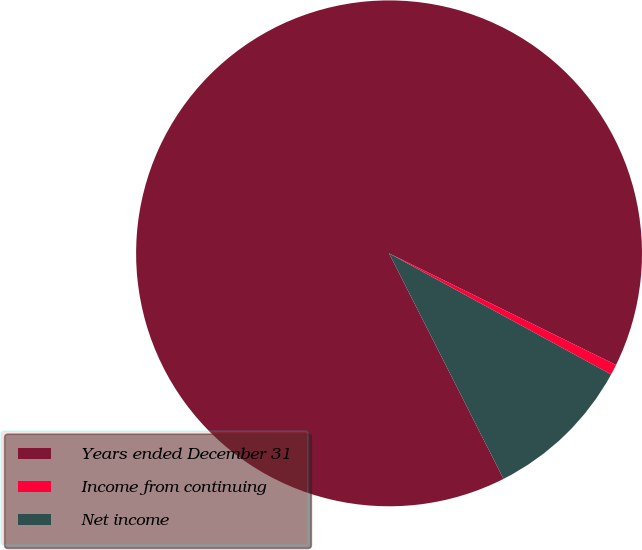Convert chart. <chart><loc_0><loc_0><loc_500><loc_500><pie_chart><fcel>Years ended December 31<fcel>Income from continuing<fcel>Net income<nl><fcel>89.75%<fcel>0.67%<fcel>9.58%<nl></chart> 